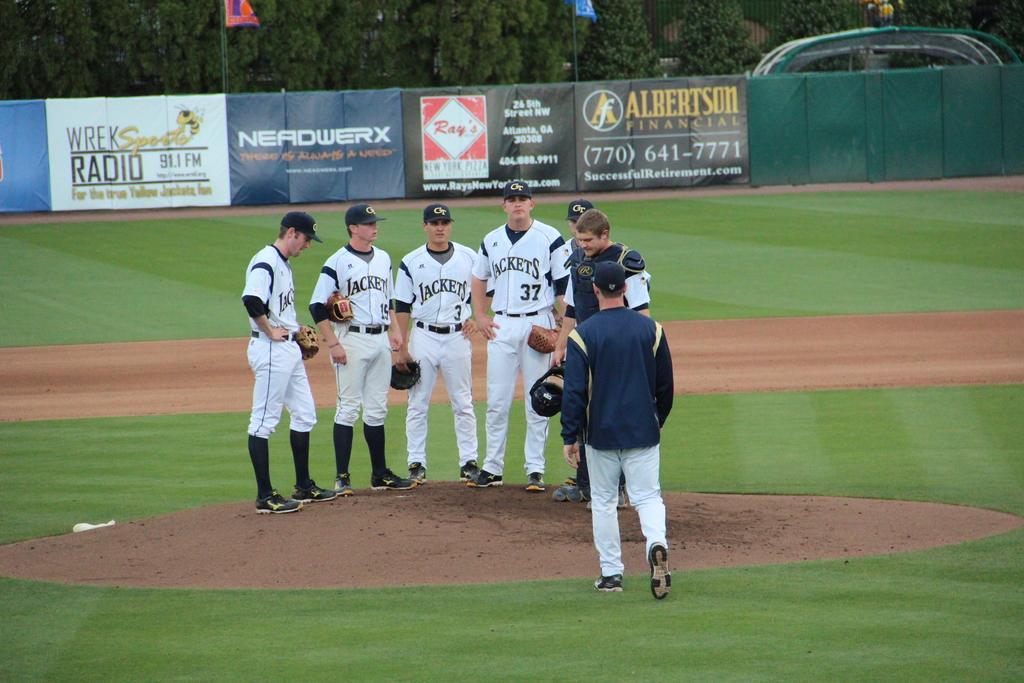In one or two sentences, can you explain what this image depicts? In this image we can see one baseball ground, two flags attached to two poles, one big wall and some banners. So many trees are there. Six people standing and holding objects. One person is walking. 